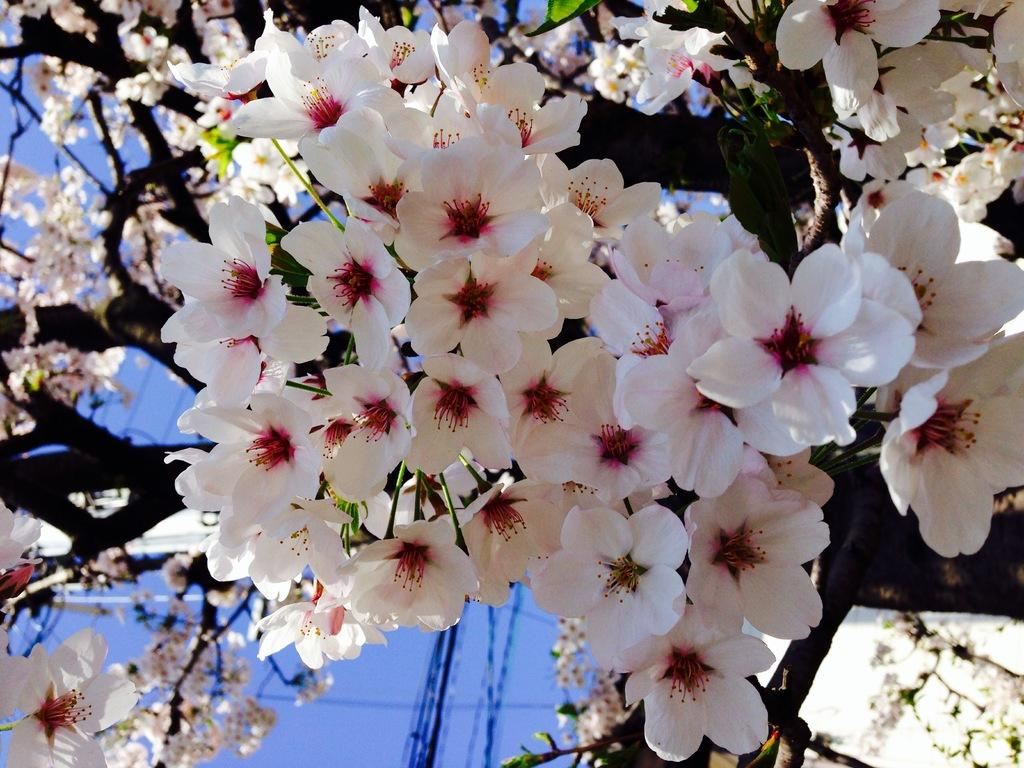What type of flora can be seen in the image? There are flowers in the image. Can you describe the colors of the flowers? The flowers are white and pink in color. What else is present in the image besides the flowers? There are tree branches in the image. What is the color of the sky in the image? The sky is blue in the image. How many dogs can be seen playing with the worm in the image? There are no dogs or worms present in the image; it features flowers, tree branches, and a blue sky. 